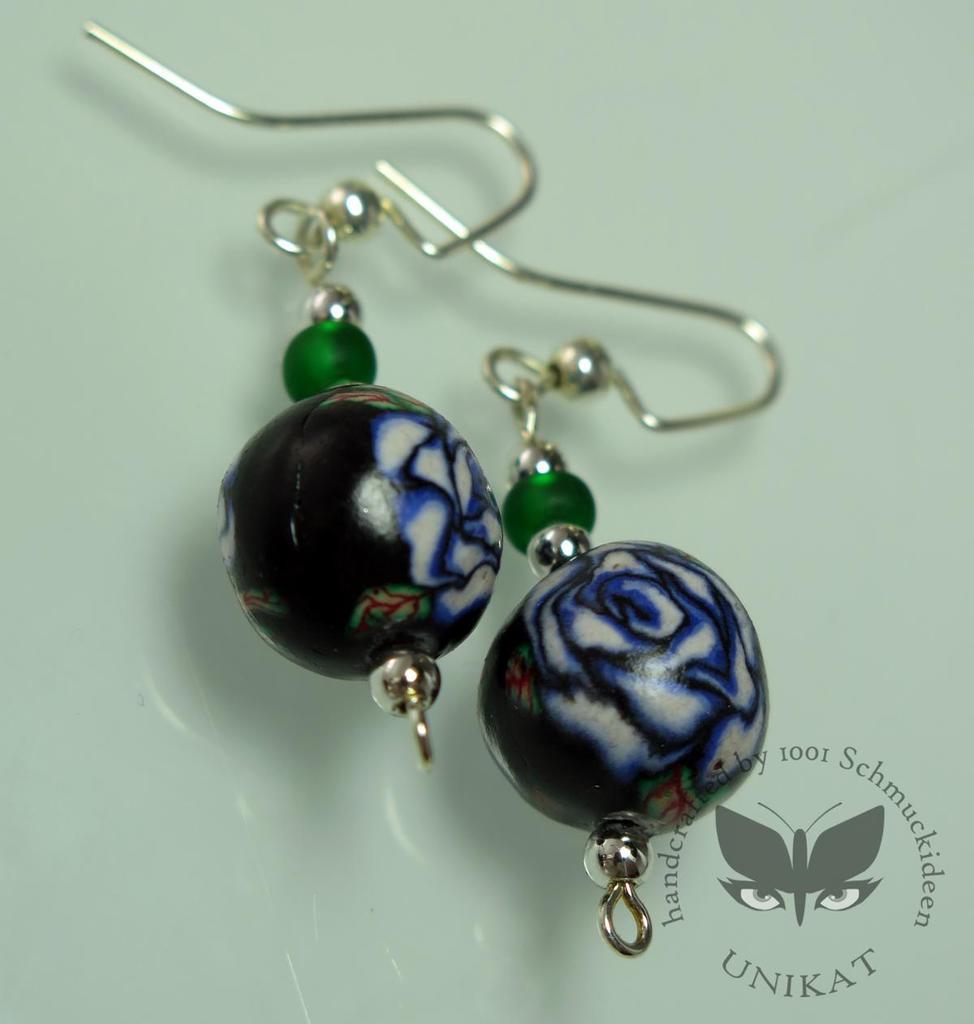Describe this image in one or two sentences. In this image we can see one pair of earrings, some text and image on the bottom right side of the image. It looks like a wall in the background. 